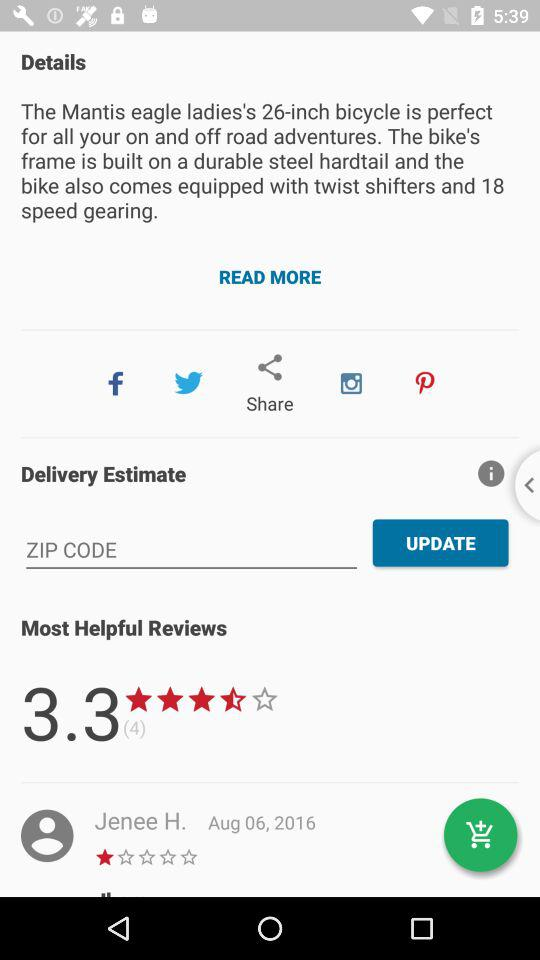What is the average rating? The average rating is 3.3. 